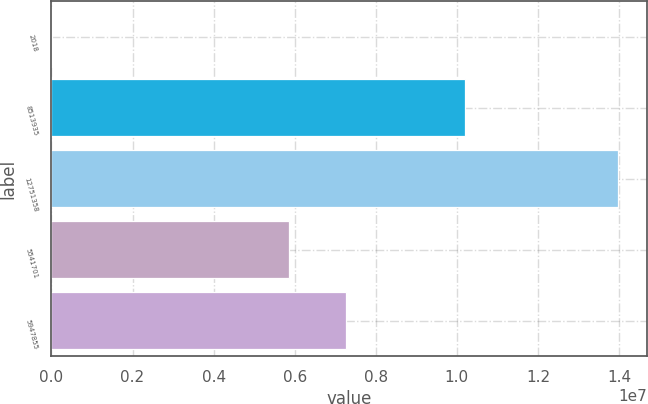<chart> <loc_0><loc_0><loc_500><loc_500><bar_chart><fcel>2018<fcel>8513935<fcel>12751358<fcel>5541701<fcel>5947855<nl><fcel>2017<fcel>1.02061e+07<fcel>1.39829e+07<fcel>5.85513e+06<fcel>7.25322e+06<nl></chart> 